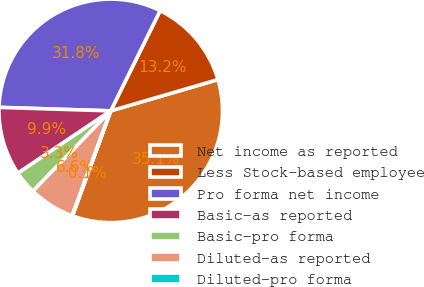Convert chart. <chart><loc_0><loc_0><loc_500><loc_500><pie_chart><fcel>Net income as reported<fcel>Less Stock-based employee<fcel>Pro forma net income<fcel>Basic-as reported<fcel>Basic-pro forma<fcel>Diluted-as reported<fcel>Diluted-pro forma<nl><fcel>35.08%<fcel>13.19%<fcel>31.8%<fcel>9.91%<fcel>3.34%<fcel>6.63%<fcel>0.06%<nl></chart> 